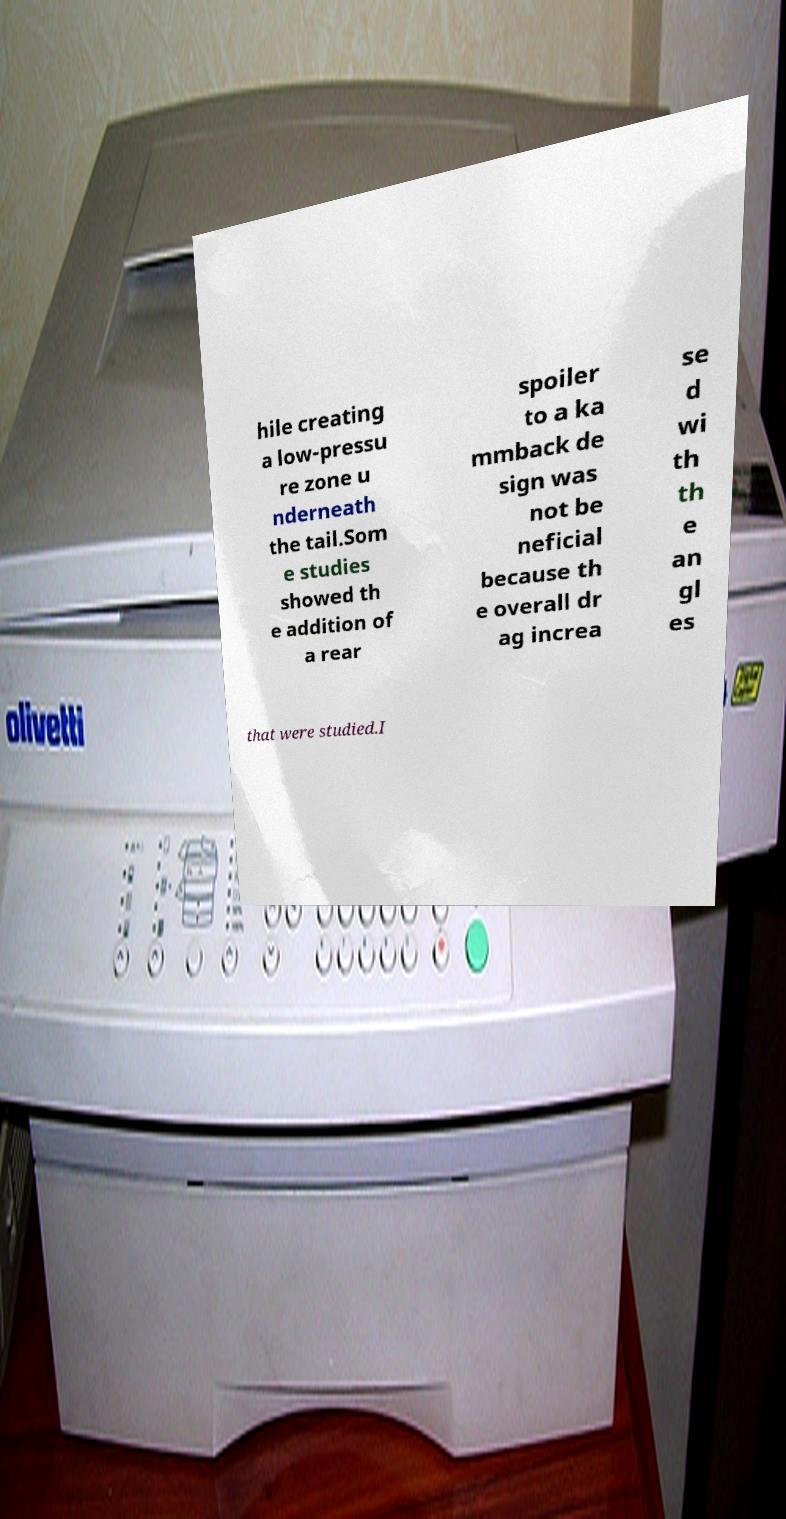There's text embedded in this image that I need extracted. Can you transcribe it verbatim? hile creating a low-pressu re zone u nderneath the tail.Som e studies showed th e addition of a rear spoiler to a ka mmback de sign was not be neficial because th e overall dr ag increa se d wi th th e an gl es that were studied.I 